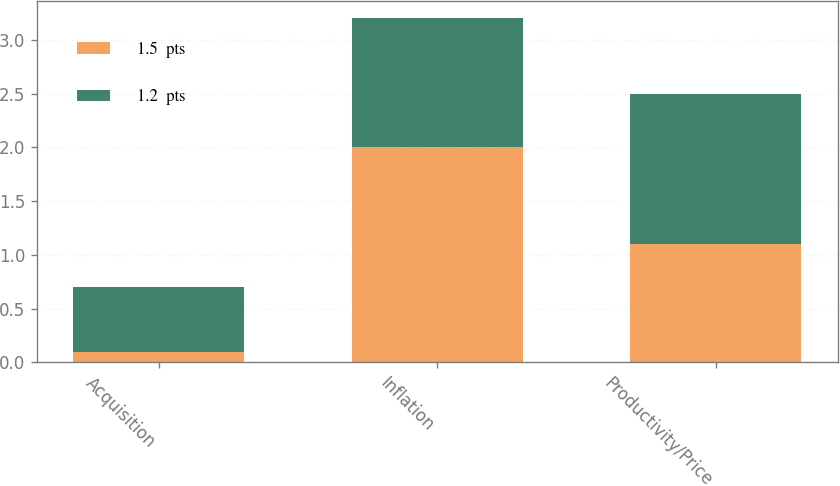Convert chart to OTSL. <chart><loc_0><loc_0><loc_500><loc_500><stacked_bar_chart><ecel><fcel>Acquisition<fcel>Inflation<fcel>Productivity/Price<nl><fcel>1.5  pts<fcel>0.1<fcel>2<fcel>1.1<nl><fcel>1.2  pts<fcel>0.6<fcel>1.2<fcel>1.4<nl></chart> 